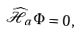Convert formula to latex. <formula><loc_0><loc_0><loc_500><loc_500>\widehat { \mathcal { H } } _ { a } \, \Phi = 0 \, ,</formula> 